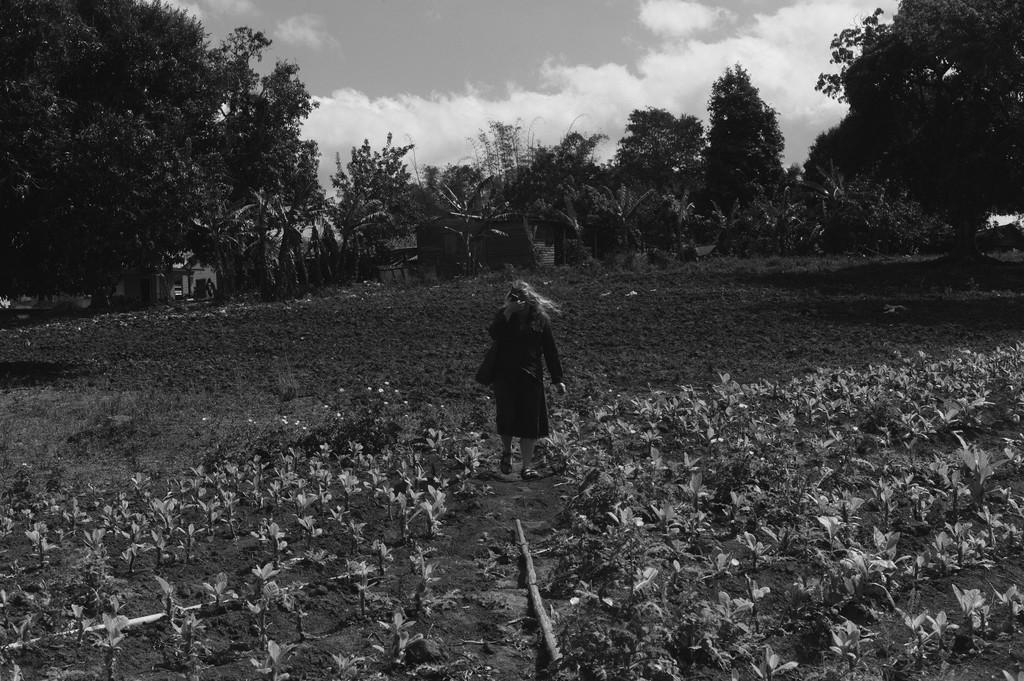Please provide a concise description of this image. This is a black and white image. In this image we can see a person standing. We can also see a group of plants with flowers, mud, a group of trees and the sky which looks cloudy. 